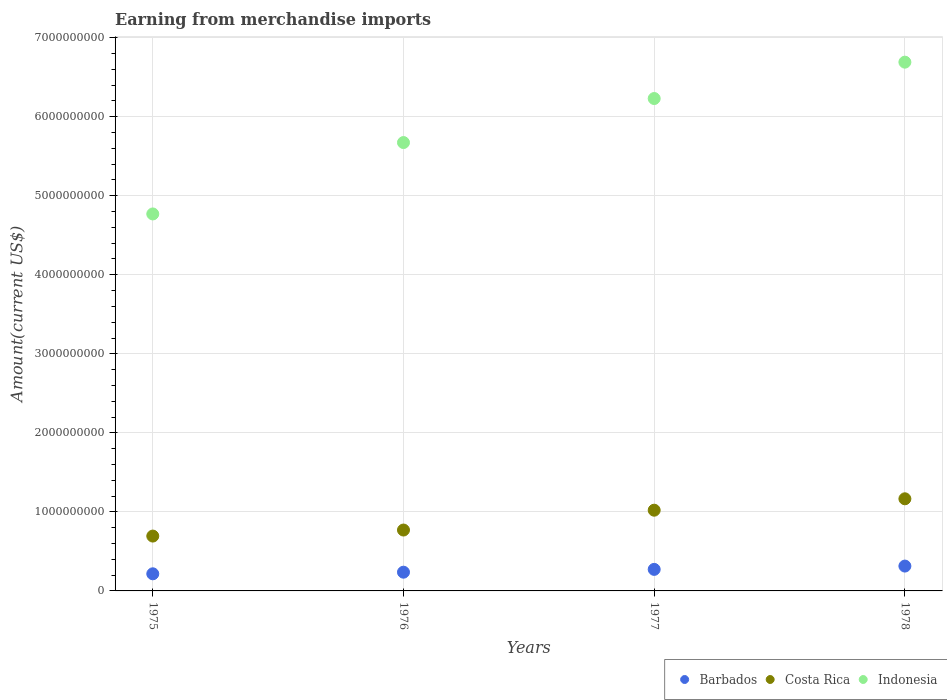What is the amount earned from merchandise imports in Costa Rica in 1976?
Provide a succinct answer. 7.70e+08. Across all years, what is the maximum amount earned from merchandise imports in Costa Rica?
Provide a succinct answer. 1.17e+09. Across all years, what is the minimum amount earned from merchandise imports in Indonesia?
Your answer should be compact. 4.77e+09. In which year was the amount earned from merchandise imports in Costa Rica maximum?
Your response must be concise. 1978. In which year was the amount earned from merchandise imports in Costa Rica minimum?
Keep it short and to the point. 1975. What is the total amount earned from merchandise imports in Barbados in the graph?
Offer a very short reply. 1.04e+09. What is the difference between the amount earned from merchandise imports in Costa Rica in 1976 and that in 1977?
Your response must be concise. -2.51e+08. What is the difference between the amount earned from merchandise imports in Indonesia in 1975 and the amount earned from merchandise imports in Barbados in 1978?
Your response must be concise. 4.46e+09. What is the average amount earned from merchandise imports in Barbados per year?
Provide a short and direct response. 2.60e+08. In the year 1977, what is the difference between the amount earned from merchandise imports in Indonesia and amount earned from merchandise imports in Costa Rica?
Ensure brevity in your answer.  5.21e+09. What is the ratio of the amount earned from merchandise imports in Barbados in 1977 to that in 1978?
Provide a short and direct response. 0.87. Is the amount earned from merchandise imports in Costa Rica in 1975 less than that in 1976?
Your answer should be very brief. Yes. What is the difference between the highest and the second highest amount earned from merchandise imports in Indonesia?
Ensure brevity in your answer.  4.60e+08. What is the difference between the highest and the lowest amount earned from merchandise imports in Costa Rica?
Make the answer very short. 4.72e+08. Is the amount earned from merchandise imports in Indonesia strictly less than the amount earned from merchandise imports in Barbados over the years?
Your response must be concise. No. How many years are there in the graph?
Provide a succinct answer. 4. What is the difference between two consecutive major ticks on the Y-axis?
Your response must be concise. 1.00e+09. Does the graph contain any zero values?
Your answer should be compact. No. Where does the legend appear in the graph?
Your response must be concise. Bottom right. How many legend labels are there?
Your answer should be very brief. 3. What is the title of the graph?
Your answer should be very brief. Earning from merchandise imports. Does "Hong Kong" appear as one of the legend labels in the graph?
Provide a short and direct response. No. What is the label or title of the X-axis?
Your response must be concise. Years. What is the label or title of the Y-axis?
Offer a terse response. Amount(current US$). What is the Amount(current US$) of Barbados in 1975?
Provide a succinct answer. 2.17e+08. What is the Amount(current US$) of Costa Rica in 1975?
Your answer should be compact. 6.94e+08. What is the Amount(current US$) of Indonesia in 1975?
Your response must be concise. 4.77e+09. What is the Amount(current US$) of Barbados in 1976?
Offer a very short reply. 2.37e+08. What is the Amount(current US$) of Costa Rica in 1976?
Your answer should be very brief. 7.70e+08. What is the Amount(current US$) of Indonesia in 1976?
Provide a succinct answer. 5.67e+09. What is the Amount(current US$) in Barbados in 1977?
Keep it short and to the point. 2.73e+08. What is the Amount(current US$) of Costa Rica in 1977?
Your response must be concise. 1.02e+09. What is the Amount(current US$) of Indonesia in 1977?
Your response must be concise. 6.23e+09. What is the Amount(current US$) of Barbados in 1978?
Offer a very short reply. 3.14e+08. What is the Amount(current US$) in Costa Rica in 1978?
Ensure brevity in your answer.  1.17e+09. What is the Amount(current US$) in Indonesia in 1978?
Your answer should be very brief. 6.69e+09. Across all years, what is the maximum Amount(current US$) in Barbados?
Provide a short and direct response. 3.14e+08. Across all years, what is the maximum Amount(current US$) in Costa Rica?
Your response must be concise. 1.17e+09. Across all years, what is the maximum Amount(current US$) of Indonesia?
Keep it short and to the point. 6.69e+09. Across all years, what is the minimum Amount(current US$) of Barbados?
Provide a succinct answer. 2.17e+08. Across all years, what is the minimum Amount(current US$) of Costa Rica?
Your answer should be very brief. 6.94e+08. Across all years, what is the minimum Amount(current US$) in Indonesia?
Ensure brevity in your answer.  4.77e+09. What is the total Amount(current US$) in Barbados in the graph?
Your response must be concise. 1.04e+09. What is the total Amount(current US$) in Costa Rica in the graph?
Your response must be concise. 3.65e+09. What is the total Amount(current US$) of Indonesia in the graph?
Offer a very short reply. 2.34e+1. What is the difference between the Amount(current US$) in Barbados in 1975 and that in 1976?
Keep it short and to the point. -2.05e+07. What is the difference between the Amount(current US$) of Costa Rica in 1975 and that in 1976?
Make the answer very short. -7.64e+07. What is the difference between the Amount(current US$) in Indonesia in 1975 and that in 1976?
Your answer should be very brief. -9.03e+08. What is the difference between the Amount(current US$) in Barbados in 1975 and that in 1977?
Your response must be concise. -5.60e+07. What is the difference between the Amount(current US$) of Costa Rica in 1975 and that in 1977?
Make the answer very short. -3.27e+08. What is the difference between the Amount(current US$) in Indonesia in 1975 and that in 1977?
Offer a very short reply. -1.46e+09. What is the difference between the Amount(current US$) in Barbados in 1975 and that in 1978?
Your answer should be compact. -9.78e+07. What is the difference between the Amount(current US$) in Costa Rica in 1975 and that in 1978?
Your answer should be compact. -4.72e+08. What is the difference between the Amount(current US$) in Indonesia in 1975 and that in 1978?
Ensure brevity in your answer.  -1.92e+09. What is the difference between the Amount(current US$) of Barbados in 1976 and that in 1977?
Keep it short and to the point. -3.55e+07. What is the difference between the Amount(current US$) of Costa Rica in 1976 and that in 1977?
Your answer should be very brief. -2.51e+08. What is the difference between the Amount(current US$) in Indonesia in 1976 and that in 1977?
Give a very brief answer. -5.57e+08. What is the difference between the Amount(current US$) in Barbados in 1976 and that in 1978?
Keep it short and to the point. -7.73e+07. What is the difference between the Amount(current US$) of Costa Rica in 1976 and that in 1978?
Make the answer very short. -3.95e+08. What is the difference between the Amount(current US$) of Indonesia in 1976 and that in 1978?
Offer a very short reply. -1.02e+09. What is the difference between the Amount(current US$) of Barbados in 1977 and that in 1978?
Your answer should be compact. -4.18e+07. What is the difference between the Amount(current US$) of Costa Rica in 1977 and that in 1978?
Offer a very short reply. -1.44e+08. What is the difference between the Amount(current US$) of Indonesia in 1977 and that in 1978?
Give a very brief answer. -4.60e+08. What is the difference between the Amount(current US$) of Barbados in 1975 and the Amount(current US$) of Costa Rica in 1976?
Provide a short and direct response. -5.54e+08. What is the difference between the Amount(current US$) in Barbados in 1975 and the Amount(current US$) in Indonesia in 1976?
Ensure brevity in your answer.  -5.46e+09. What is the difference between the Amount(current US$) of Costa Rica in 1975 and the Amount(current US$) of Indonesia in 1976?
Offer a very short reply. -4.98e+09. What is the difference between the Amount(current US$) of Barbados in 1975 and the Amount(current US$) of Costa Rica in 1977?
Ensure brevity in your answer.  -8.05e+08. What is the difference between the Amount(current US$) of Barbados in 1975 and the Amount(current US$) of Indonesia in 1977?
Give a very brief answer. -6.01e+09. What is the difference between the Amount(current US$) of Costa Rica in 1975 and the Amount(current US$) of Indonesia in 1977?
Offer a very short reply. -5.54e+09. What is the difference between the Amount(current US$) of Barbados in 1975 and the Amount(current US$) of Costa Rica in 1978?
Keep it short and to the point. -9.49e+08. What is the difference between the Amount(current US$) of Barbados in 1975 and the Amount(current US$) of Indonesia in 1978?
Give a very brief answer. -6.47e+09. What is the difference between the Amount(current US$) of Costa Rica in 1975 and the Amount(current US$) of Indonesia in 1978?
Your response must be concise. -6.00e+09. What is the difference between the Amount(current US$) of Barbados in 1976 and the Amount(current US$) of Costa Rica in 1977?
Your answer should be compact. -7.84e+08. What is the difference between the Amount(current US$) of Barbados in 1976 and the Amount(current US$) of Indonesia in 1977?
Keep it short and to the point. -5.99e+09. What is the difference between the Amount(current US$) of Costa Rica in 1976 and the Amount(current US$) of Indonesia in 1977?
Provide a succinct answer. -5.46e+09. What is the difference between the Amount(current US$) in Barbados in 1976 and the Amount(current US$) in Costa Rica in 1978?
Your answer should be compact. -9.29e+08. What is the difference between the Amount(current US$) of Barbados in 1976 and the Amount(current US$) of Indonesia in 1978?
Provide a succinct answer. -6.45e+09. What is the difference between the Amount(current US$) of Costa Rica in 1976 and the Amount(current US$) of Indonesia in 1978?
Provide a short and direct response. -5.92e+09. What is the difference between the Amount(current US$) in Barbados in 1977 and the Amount(current US$) in Costa Rica in 1978?
Make the answer very short. -8.93e+08. What is the difference between the Amount(current US$) of Barbados in 1977 and the Amount(current US$) of Indonesia in 1978?
Provide a short and direct response. -6.42e+09. What is the difference between the Amount(current US$) in Costa Rica in 1977 and the Amount(current US$) in Indonesia in 1978?
Your response must be concise. -5.67e+09. What is the average Amount(current US$) in Barbados per year?
Your answer should be compact. 2.60e+08. What is the average Amount(current US$) in Costa Rica per year?
Give a very brief answer. 9.13e+08. What is the average Amount(current US$) in Indonesia per year?
Your answer should be compact. 5.84e+09. In the year 1975, what is the difference between the Amount(current US$) in Barbados and Amount(current US$) in Costa Rica?
Your answer should be very brief. -4.77e+08. In the year 1975, what is the difference between the Amount(current US$) in Barbados and Amount(current US$) in Indonesia?
Provide a short and direct response. -4.55e+09. In the year 1975, what is the difference between the Amount(current US$) in Costa Rica and Amount(current US$) in Indonesia?
Make the answer very short. -4.08e+09. In the year 1976, what is the difference between the Amount(current US$) in Barbados and Amount(current US$) in Costa Rica?
Give a very brief answer. -5.33e+08. In the year 1976, what is the difference between the Amount(current US$) of Barbados and Amount(current US$) of Indonesia?
Your answer should be very brief. -5.44e+09. In the year 1976, what is the difference between the Amount(current US$) of Costa Rica and Amount(current US$) of Indonesia?
Your answer should be compact. -4.90e+09. In the year 1977, what is the difference between the Amount(current US$) in Barbados and Amount(current US$) in Costa Rica?
Provide a short and direct response. -7.49e+08. In the year 1977, what is the difference between the Amount(current US$) of Barbados and Amount(current US$) of Indonesia?
Offer a terse response. -5.96e+09. In the year 1977, what is the difference between the Amount(current US$) of Costa Rica and Amount(current US$) of Indonesia?
Your answer should be compact. -5.21e+09. In the year 1978, what is the difference between the Amount(current US$) of Barbados and Amount(current US$) of Costa Rica?
Offer a very short reply. -8.51e+08. In the year 1978, what is the difference between the Amount(current US$) in Barbados and Amount(current US$) in Indonesia?
Offer a very short reply. -6.38e+09. In the year 1978, what is the difference between the Amount(current US$) in Costa Rica and Amount(current US$) in Indonesia?
Your response must be concise. -5.52e+09. What is the ratio of the Amount(current US$) in Barbados in 1975 to that in 1976?
Give a very brief answer. 0.91. What is the ratio of the Amount(current US$) of Costa Rica in 1975 to that in 1976?
Give a very brief answer. 0.9. What is the ratio of the Amount(current US$) in Indonesia in 1975 to that in 1976?
Provide a short and direct response. 0.84. What is the ratio of the Amount(current US$) in Barbados in 1975 to that in 1977?
Your answer should be compact. 0.79. What is the ratio of the Amount(current US$) in Costa Rica in 1975 to that in 1977?
Provide a succinct answer. 0.68. What is the ratio of the Amount(current US$) of Indonesia in 1975 to that in 1977?
Offer a terse response. 0.77. What is the ratio of the Amount(current US$) of Barbados in 1975 to that in 1978?
Your answer should be very brief. 0.69. What is the ratio of the Amount(current US$) in Costa Rica in 1975 to that in 1978?
Your answer should be very brief. 0.6. What is the ratio of the Amount(current US$) of Indonesia in 1975 to that in 1978?
Offer a terse response. 0.71. What is the ratio of the Amount(current US$) of Barbados in 1976 to that in 1977?
Offer a very short reply. 0.87. What is the ratio of the Amount(current US$) of Costa Rica in 1976 to that in 1977?
Provide a short and direct response. 0.75. What is the ratio of the Amount(current US$) of Indonesia in 1976 to that in 1977?
Give a very brief answer. 0.91. What is the ratio of the Amount(current US$) in Barbados in 1976 to that in 1978?
Your answer should be compact. 0.75. What is the ratio of the Amount(current US$) of Costa Rica in 1976 to that in 1978?
Give a very brief answer. 0.66. What is the ratio of the Amount(current US$) of Indonesia in 1976 to that in 1978?
Your response must be concise. 0.85. What is the ratio of the Amount(current US$) in Barbados in 1977 to that in 1978?
Offer a very short reply. 0.87. What is the ratio of the Amount(current US$) in Costa Rica in 1977 to that in 1978?
Ensure brevity in your answer.  0.88. What is the ratio of the Amount(current US$) of Indonesia in 1977 to that in 1978?
Your response must be concise. 0.93. What is the difference between the highest and the second highest Amount(current US$) of Barbados?
Make the answer very short. 4.18e+07. What is the difference between the highest and the second highest Amount(current US$) of Costa Rica?
Offer a very short reply. 1.44e+08. What is the difference between the highest and the second highest Amount(current US$) of Indonesia?
Make the answer very short. 4.60e+08. What is the difference between the highest and the lowest Amount(current US$) in Barbados?
Your response must be concise. 9.78e+07. What is the difference between the highest and the lowest Amount(current US$) in Costa Rica?
Your response must be concise. 4.72e+08. What is the difference between the highest and the lowest Amount(current US$) of Indonesia?
Offer a terse response. 1.92e+09. 